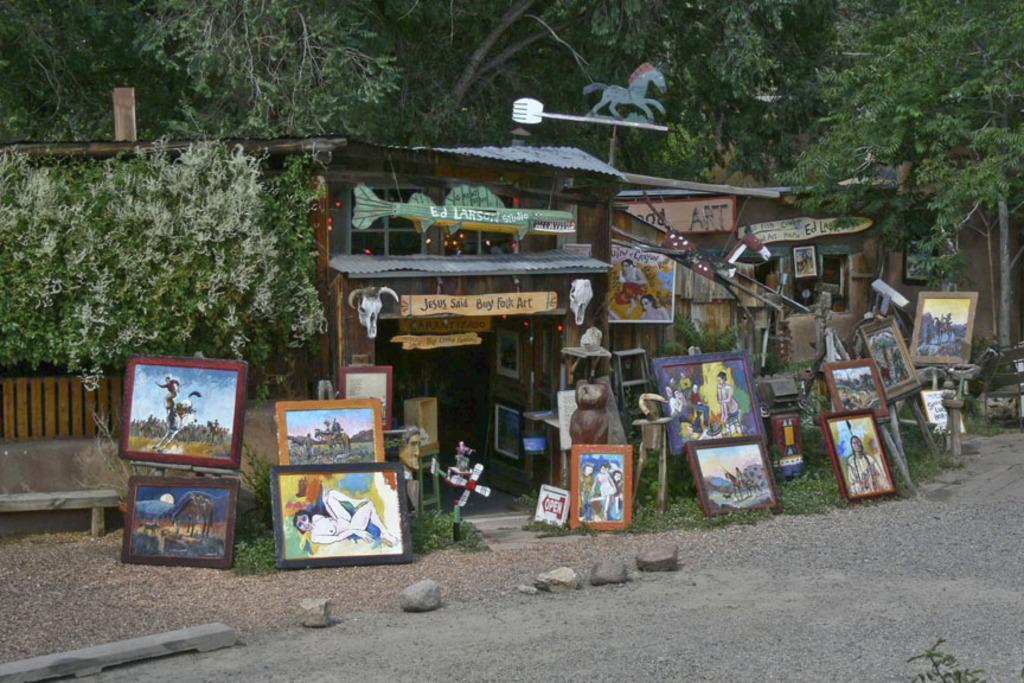Can you describe this image briefly? In this image I see the stones and I see number of photo frames over here and I see something is written over here and I see the path and I see few stones over here and I see the bench over here. In the background I see the trees. 